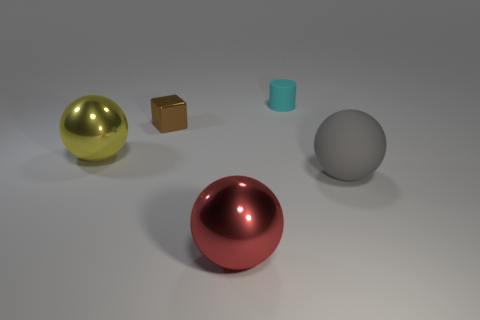Add 2 small cyan cylinders. How many objects exist? 7 Subtract all spheres. How many objects are left? 2 Subtract all big red metal things. Subtract all shiny blocks. How many objects are left? 3 Add 4 small cyan cylinders. How many small cyan cylinders are left? 5 Add 4 gray spheres. How many gray spheres exist? 5 Subtract 0 yellow cylinders. How many objects are left? 5 